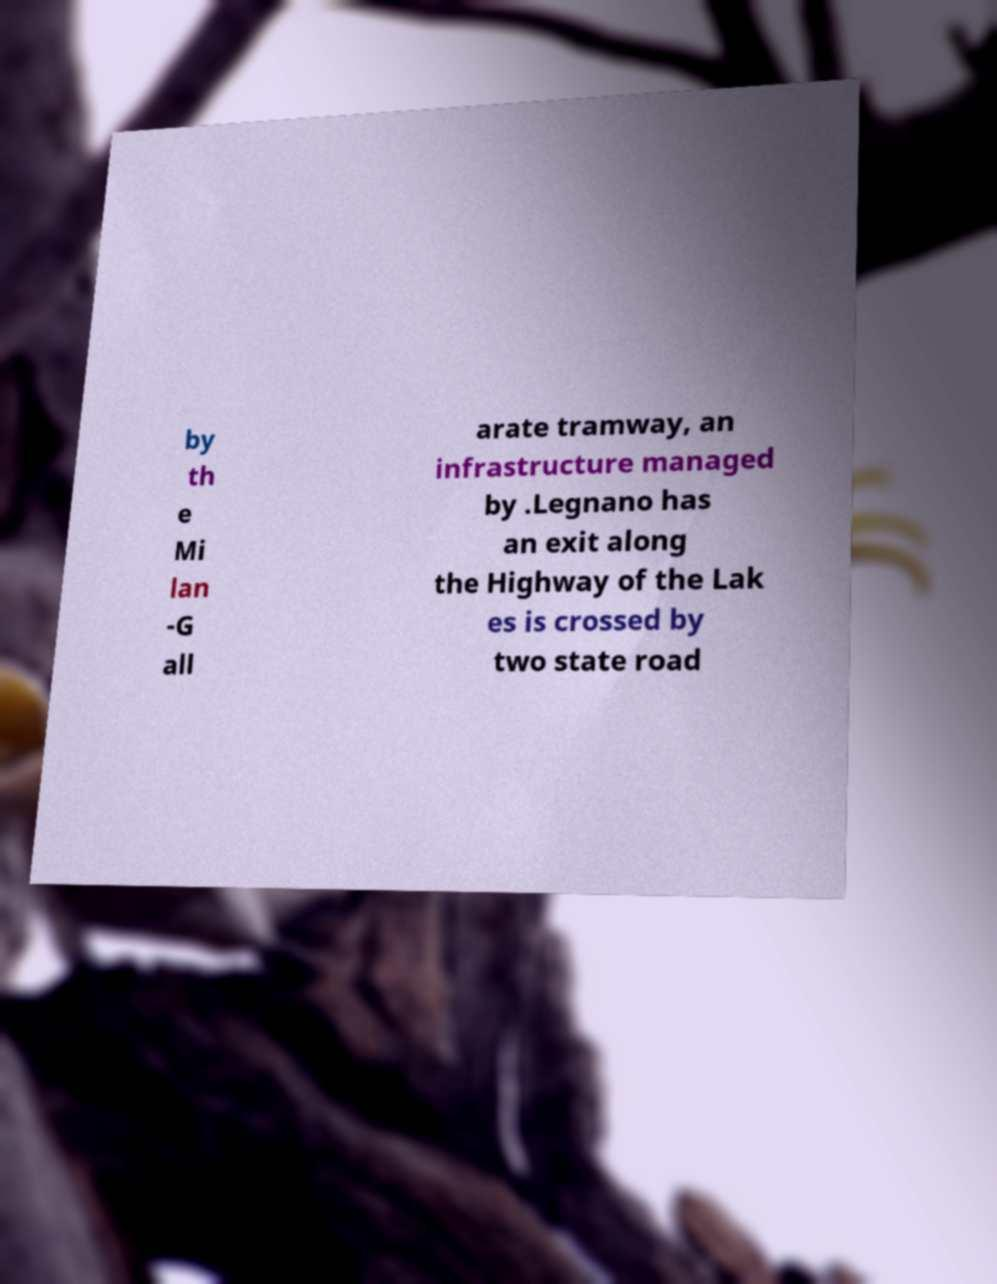Could you assist in decoding the text presented in this image and type it out clearly? by th e Mi lan -G all arate tramway, an infrastructure managed by .Legnano has an exit along the Highway of the Lak es is crossed by two state road 